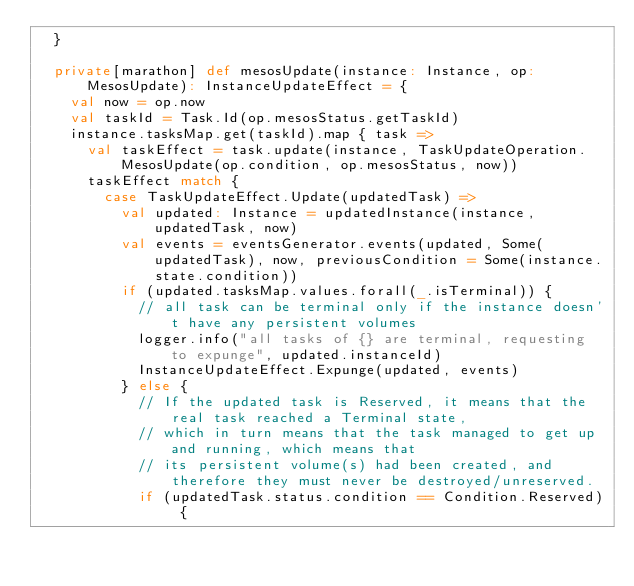<code> <loc_0><loc_0><loc_500><loc_500><_Scala_>  }

  private[marathon] def mesosUpdate(instance: Instance, op: MesosUpdate): InstanceUpdateEffect = {
    val now = op.now
    val taskId = Task.Id(op.mesosStatus.getTaskId)
    instance.tasksMap.get(taskId).map { task =>
      val taskEffect = task.update(instance, TaskUpdateOperation.MesosUpdate(op.condition, op.mesosStatus, now))
      taskEffect match {
        case TaskUpdateEffect.Update(updatedTask) =>
          val updated: Instance = updatedInstance(instance, updatedTask, now)
          val events = eventsGenerator.events(updated, Some(updatedTask), now, previousCondition = Some(instance.state.condition))
          if (updated.tasksMap.values.forall(_.isTerminal)) {
            // all task can be terminal only if the instance doesn't have any persistent volumes
            logger.info("all tasks of {} are terminal, requesting to expunge", updated.instanceId)
            InstanceUpdateEffect.Expunge(updated, events)
          } else {
            // If the updated task is Reserved, it means that the real task reached a Terminal state,
            // which in turn means that the task managed to get up and running, which means that
            // its persistent volume(s) had been created, and therefore they must never be destroyed/unreserved.
            if (updatedTask.status.condition == Condition.Reserved) {</code> 